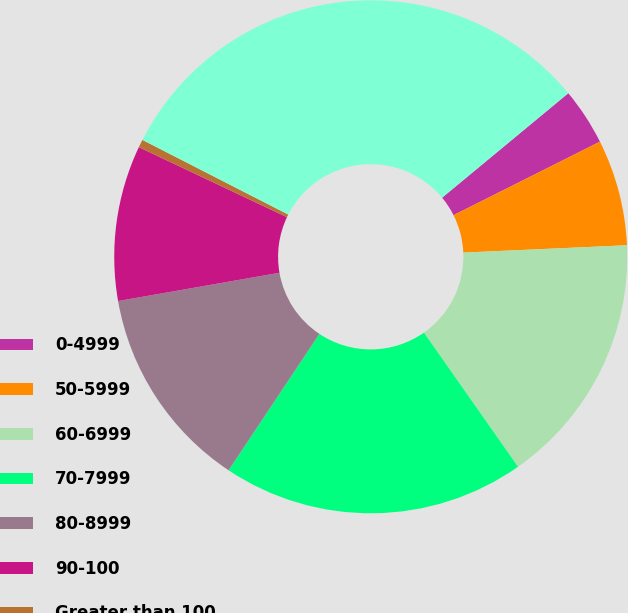<chart> <loc_0><loc_0><loc_500><loc_500><pie_chart><fcel>0-4999<fcel>50-5999<fcel>60-6999<fcel>70-7999<fcel>80-8999<fcel>90-100<fcel>Greater than 100<fcel>Total Industrial<nl><fcel>3.6%<fcel>6.69%<fcel>15.98%<fcel>19.08%<fcel>12.89%<fcel>9.79%<fcel>0.5%<fcel>31.46%<nl></chart> 